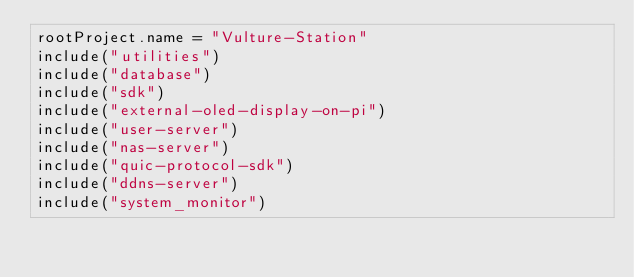Convert code to text. <code><loc_0><loc_0><loc_500><loc_500><_Kotlin_>rootProject.name = "Vulture-Station"
include("utilities")
include("database")
include("sdk")
include("external-oled-display-on-pi")
include("user-server")
include("nas-server")
include("quic-protocol-sdk")
include("ddns-server")
include("system_monitor")</code> 